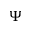<formula> <loc_0><loc_0><loc_500><loc_500>\Psi</formula> 